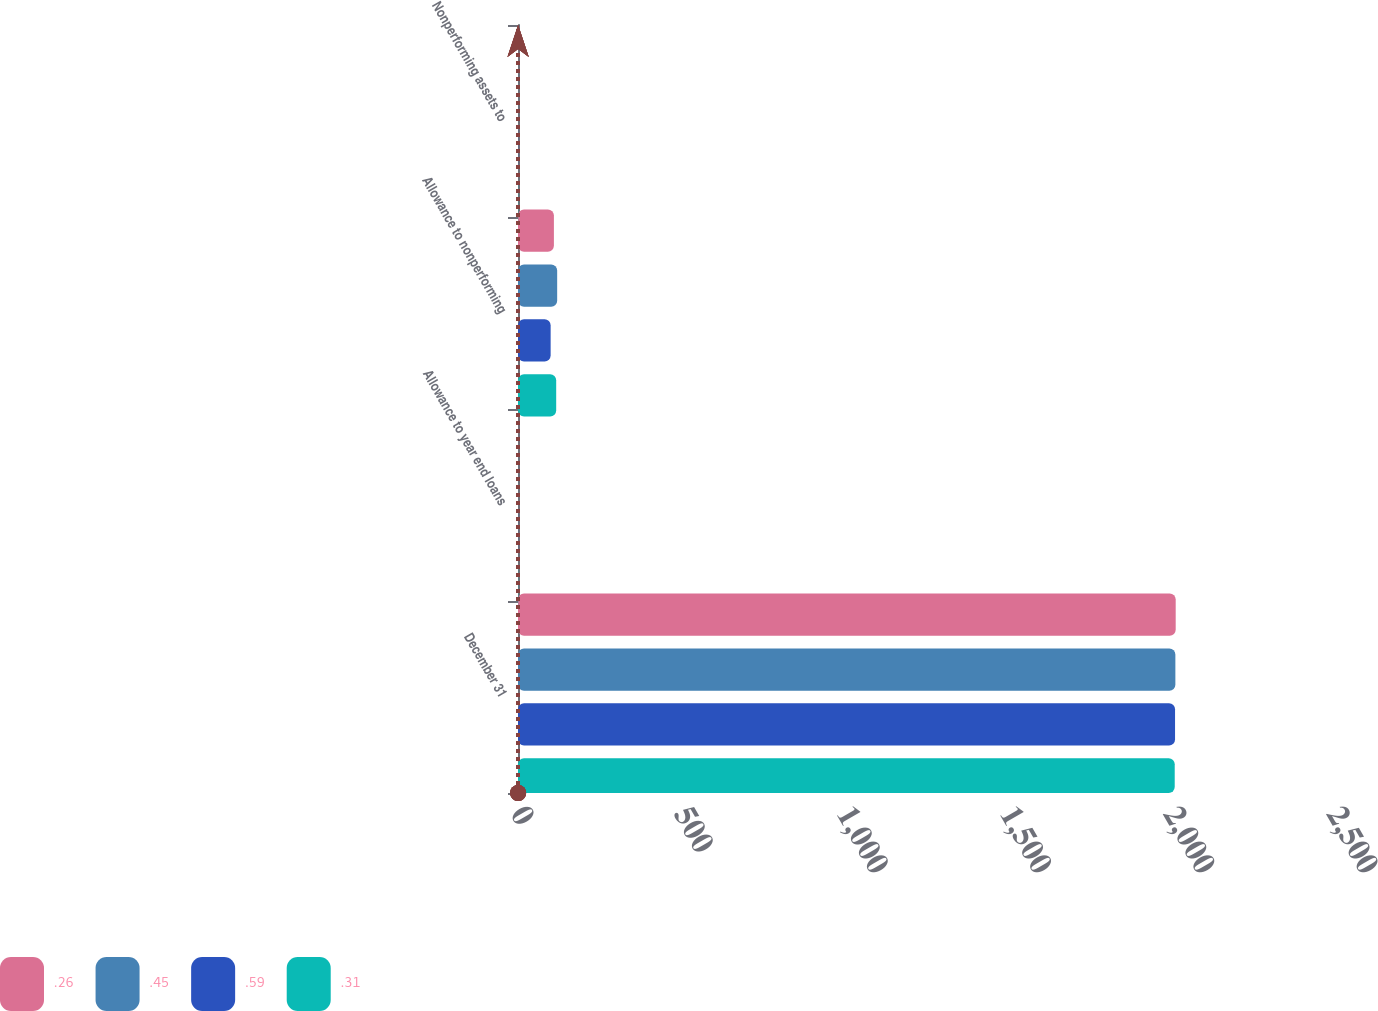Convert chart to OTSL. <chart><loc_0><loc_0><loc_500><loc_500><stacked_bar_chart><ecel><fcel>December 31<fcel>Allowance to year end loans<fcel>Allowance to nonperforming<fcel>Nonperforming assets to<nl><fcel>0.26<fcel>2015<fcel>0.21<fcel>110<fcel>0.26<nl><fcel>0.45<fcel>2014<fcel>0.31<fcel>120<fcel>0.31<nl><fcel>0.59<fcel>2013<fcel>0.39<fcel>100<fcel>0.45<nl><fcel>0.31<fcel>2012<fcel>0.52<fcel>117<fcel>0.54<nl></chart> 